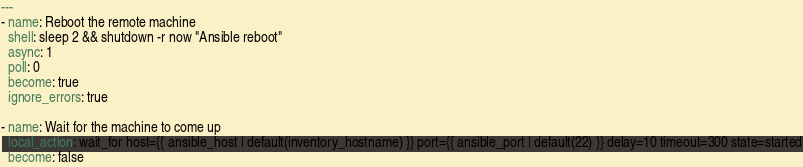Convert code to text. <code><loc_0><loc_0><loc_500><loc_500><_YAML_>---
- name: Reboot the remote machine
  shell: sleep 2 && shutdown -r now "Ansible reboot"
  async: 1
  poll: 0
  become: true
  ignore_errors: true

- name: Wait for the machine to come up
  local_action: wait_for host={{ ansible_host | default(inventory_hostname) }} port={{ ansible_port | default(22) }} delay=10 timeout=300 state=started
  become: false
</code> 